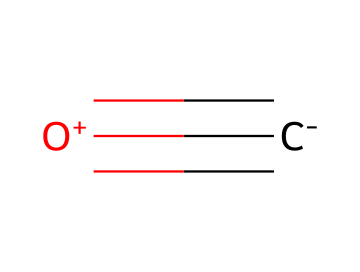What is the molecular formula of this chemical? The SMILES representation indicates the presence of one carbon atom (C) and one oxygen atom (O) in the structure. Therefore, the molecular formula is CO.
Answer: CO How many total atoms are present in this chemical? The SMILES representation shows one carbon atom and one oxygen atom, adding up to a total of two atoms.
Answer: 2 What is the hybridization of the carbon atom in this chemical? In carbon monoxide, the carbon atom is involved in a triple bond with oxygen, which indicates that it has sp hybridization since it is linearly arranged.
Answer: sp Is this chemical a gas at room temperature? Carbon monoxide is known to be a gas under standard temperature and pressure conditions, indicating its physical state.
Answer: yes What type of bond exists between the carbon and oxygen in this chemical? The notation in the SMILES indicates the presence of a triple bond between the carbon and oxygen, which classifies it as a strong bond.
Answer: triple bond What is a major health risk associated with this chemical? Carbon monoxide is known to be a toxic gas that poses risks such as suffocation and poisoning when inhaled, particularly in poorly ventilated areas.
Answer: poisoning How does this chemical typically affect living organisms? Carbon monoxide binds to hemoglobin in the blood more effectively than oxygen, reducing the oxygen-carrying capacity, leading to potential health issues in organisms.
Answer: suffocation 